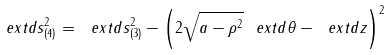<formula> <loc_0><loc_0><loc_500><loc_500>\ e x t d s ^ { 2 } _ { ( 4 ) } = \ e x t d s ^ { 2 } _ { ( 3 ) } - \left ( 2 \sqrt { a - \rho ^ { 2 } } \ e x t d \theta - \ e x t d z \right ) ^ { 2 }</formula> 